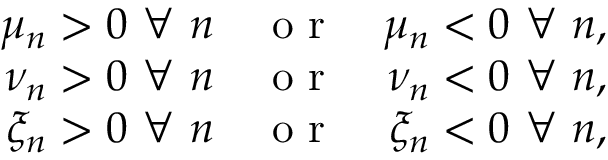Convert formula to latex. <formula><loc_0><loc_0><loc_500><loc_500>\begin{array} { r l r } { \mu _ { n } > 0 \forall n } & o r } & { \mu _ { n } < 0 \forall n , } \\ { \nu _ { n } > 0 \forall n } & o r } & { \nu _ { n } < 0 \forall n , } \\ { \xi _ { n } > 0 \forall n } & o r } & { \xi _ { n } < 0 \forall n , } \end{array}</formula> 